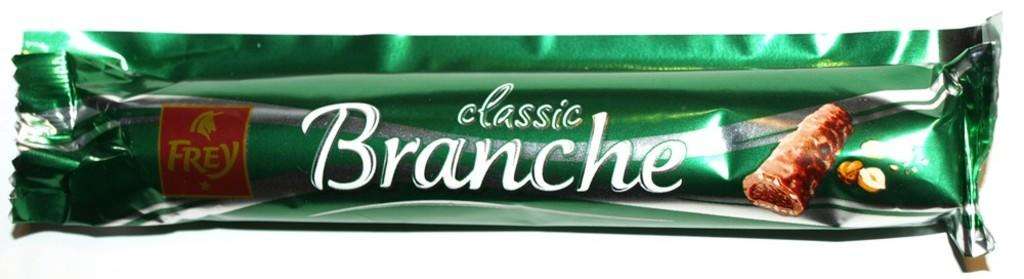Provide a one-sentence caption for the provided image. A Classic Branche candy bar with a white background. 